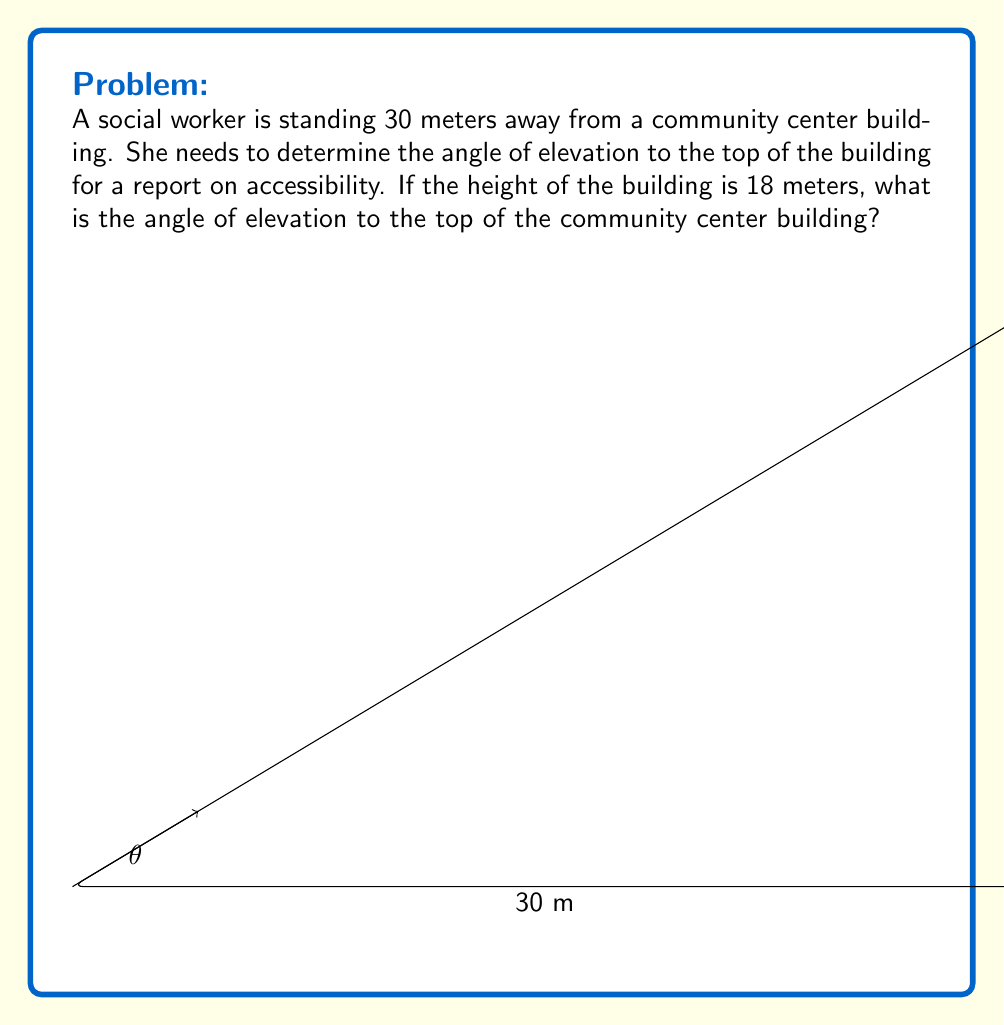Could you help me with this problem? To solve this problem, we'll use trigonometry, specifically the tangent function.

1) In this scenario, we have a right triangle where:
   - The adjacent side is the distance from the social worker to the building (30 meters)
   - The opposite side is the height of the building (18 meters)
   - The angle we're looking for is the angle of elevation ($\theta$)

2) The tangent of an angle in a right triangle is defined as the ratio of the opposite side to the adjacent side:

   $$\tan(\theta) = \frac{\text{opposite}}{\text{adjacent}}$$

3) Substituting our values:

   $$\tan(\theta) = \frac{18}{30}$$

4) Simplify the fraction:

   $$\tan(\theta) = \frac{3}{5} = 0.6$$

5) To find the angle $\theta$, we need to use the inverse tangent (arctan or $\tan^{-1}$) function:

   $$\theta = \tan^{-1}(0.6)$$

6) Using a calculator or trigonometric tables:

   $$\theta \approx 30.96^\circ$$

Therefore, the angle of elevation to the top of the community center building is approximately 30.96°.
Answer: $\theta \approx 30.96^\circ$ 